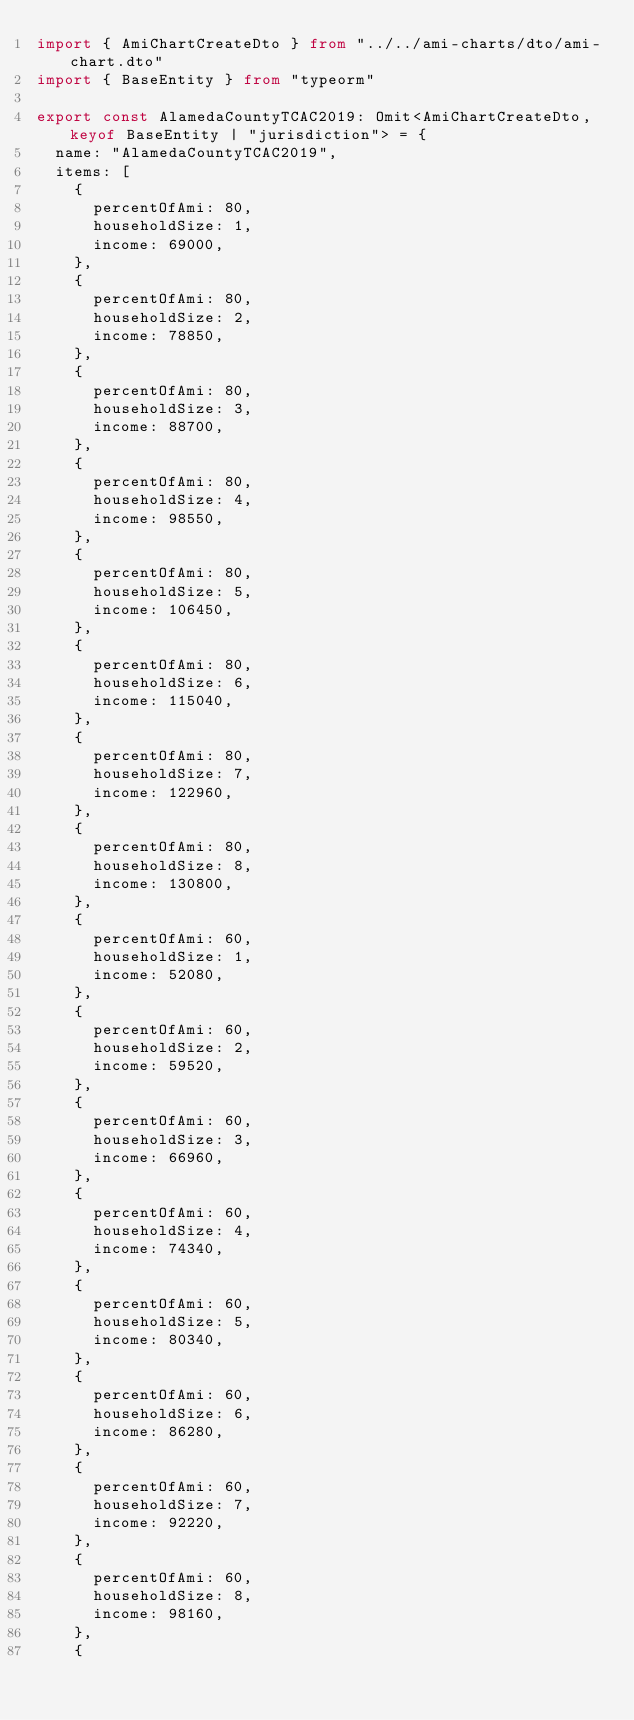Convert code to text. <code><loc_0><loc_0><loc_500><loc_500><_TypeScript_>import { AmiChartCreateDto } from "../../ami-charts/dto/ami-chart.dto"
import { BaseEntity } from "typeorm"

export const AlamedaCountyTCAC2019: Omit<AmiChartCreateDto, keyof BaseEntity | "jurisdiction"> = {
  name: "AlamedaCountyTCAC2019",
  items: [
    {
      percentOfAmi: 80,
      householdSize: 1,
      income: 69000,
    },
    {
      percentOfAmi: 80,
      householdSize: 2,
      income: 78850,
    },
    {
      percentOfAmi: 80,
      householdSize: 3,
      income: 88700,
    },
    {
      percentOfAmi: 80,
      householdSize: 4,
      income: 98550,
    },
    {
      percentOfAmi: 80,
      householdSize: 5,
      income: 106450,
    },
    {
      percentOfAmi: 80,
      householdSize: 6,
      income: 115040,
    },
    {
      percentOfAmi: 80,
      householdSize: 7,
      income: 122960,
    },
    {
      percentOfAmi: 80,
      householdSize: 8,
      income: 130800,
    },
    {
      percentOfAmi: 60,
      householdSize: 1,
      income: 52080,
    },
    {
      percentOfAmi: 60,
      householdSize: 2,
      income: 59520,
    },
    {
      percentOfAmi: 60,
      householdSize: 3,
      income: 66960,
    },
    {
      percentOfAmi: 60,
      householdSize: 4,
      income: 74340,
    },
    {
      percentOfAmi: 60,
      householdSize: 5,
      income: 80340,
    },
    {
      percentOfAmi: 60,
      householdSize: 6,
      income: 86280,
    },
    {
      percentOfAmi: 60,
      householdSize: 7,
      income: 92220,
    },
    {
      percentOfAmi: 60,
      householdSize: 8,
      income: 98160,
    },
    {</code> 